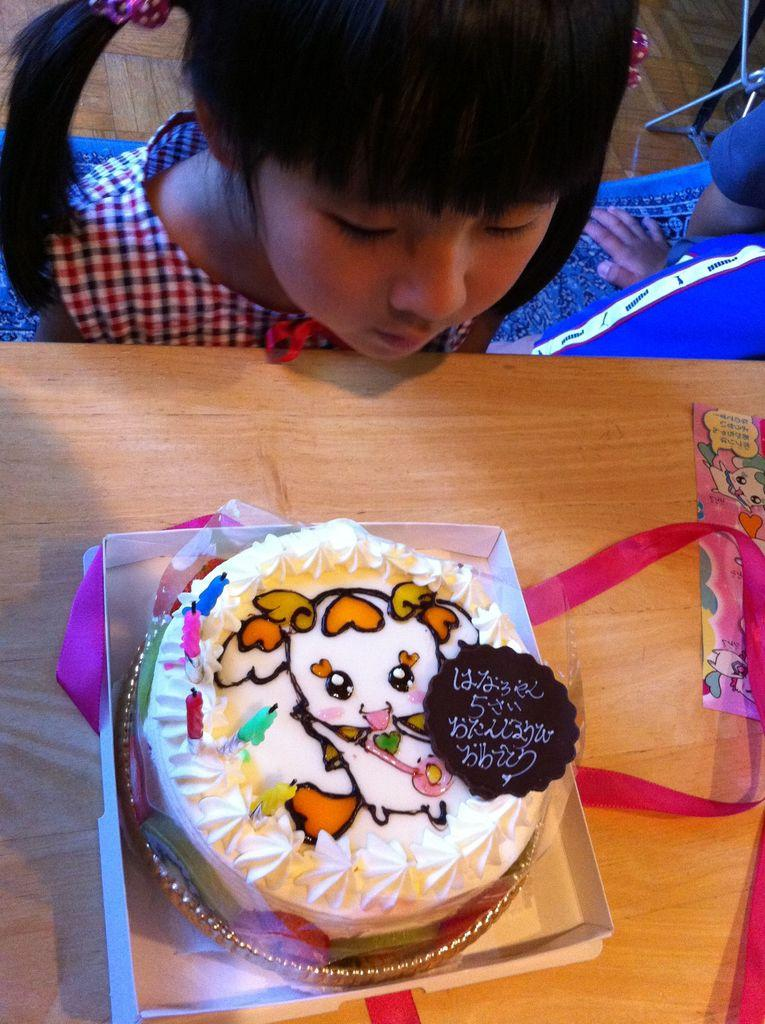What is the main piece of furniture in the image? There is a table in the image. What is placed on the table? There is a cake on the table. Who is present at the table? There is a kid sitting at the table. What color is the crayon used to draw on the hospital wall in the image? There is no crayon or hospital wall present in the image. 